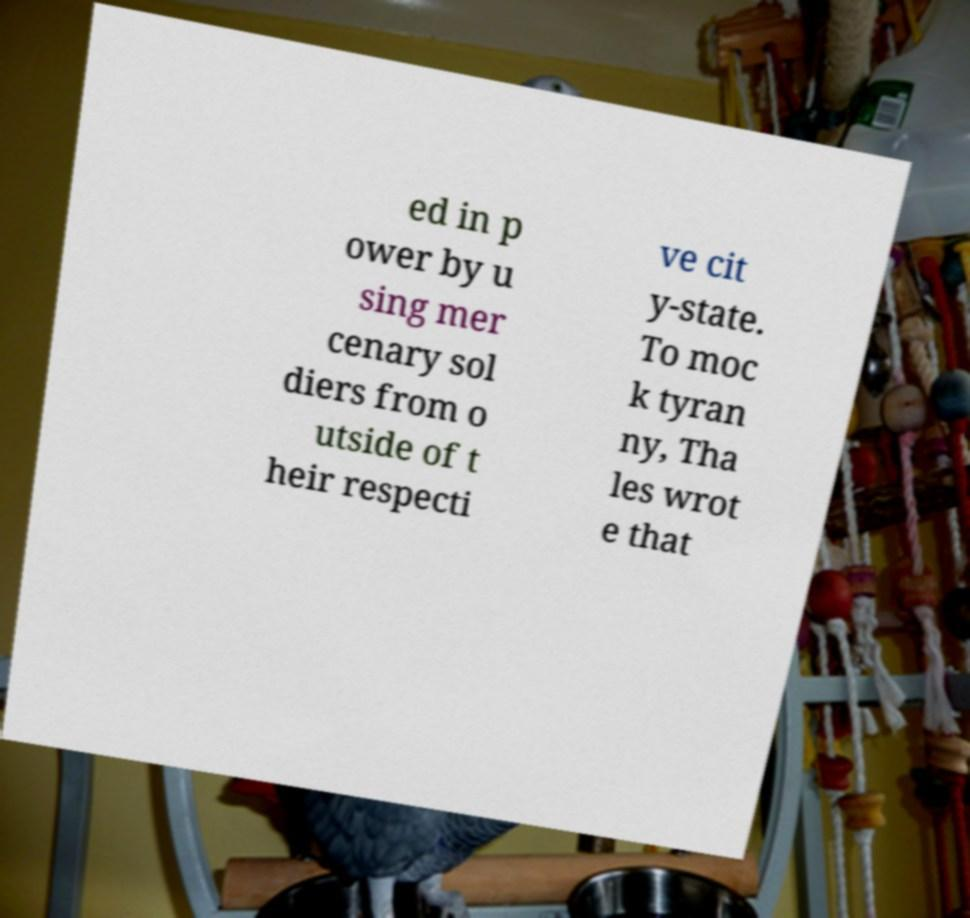Can you accurately transcribe the text from the provided image for me? ed in p ower by u sing mer cenary sol diers from o utside of t heir respecti ve cit y-state. To moc k tyran ny, Tha les wrot e that 